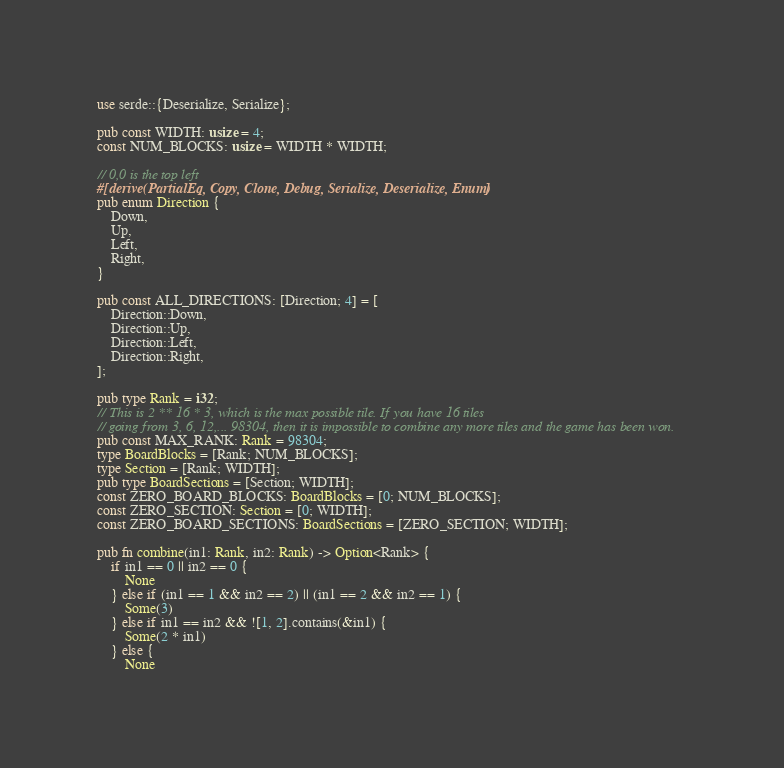Convert code to text. <code><loc_0><loc_0><loc_500><loc_500><_Rust_>use serde::{Deserialize, Serialize};

pub const WIDTH: usize = 4;
const NUM_BLOCKS: usize = WIDTH * WIDTH;

// 0,0 is the top left
#[derive(PartialEq, Copy, Clone, Debug, Serialize, Deserialize, Enum)]
pub enum Direction {
    Down,
    Up,
    Left,
    Right,
}

pub const ALL_DIRECTIONS: [Direction; 4] = [
    Direction::Down,
    Direction::Up,
    Direction::Left,
    Direction::Right,
];

pub type Rank = i32;
// This is 2 ** 16 * 3, which is the max possible tile. If you have 16 tiles
// going from 3, 6, 12,... 98304, then it is impossible to combine any more tiles and the game has been won.
pub const MAX_RANK: Rank = 98304;
type BoardBlocks = [Rank; NUM_BLOCKS];
type Section = [Rank; WIDTH];
pub type BoardSections = [Section; WIDTH];
const ZERO_BOARD_BLOCKS: BoardBlocks = [0; NUM_BLOCKS];
const ZERO_SECTION: Section = [0; WIDTH];
const ZERO_BOARD_SECTIONS: BoardSections = [ZERO_SECTION; WIDTH];

pub fn combine(in1: Rank, in2: Rank) -> Option<Rank> {
    if in1 == 0 || in2 == 0 {
        None
    } else if (in1 == 1 && in2 == 2) || (in1 == 2 && in2 == 1) {
        Some(3)
    } else if in1 == in2 && ![1, 2].contains(&in1) {
        Some(2 * in1)
    } else {
        None</code> 